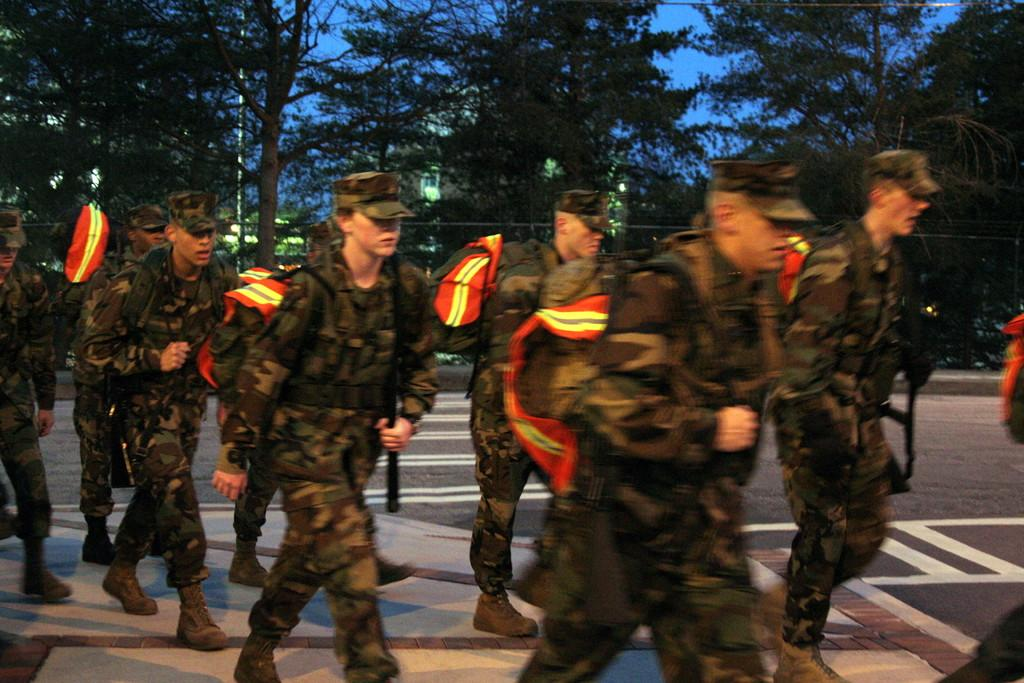Who is present in the image? There are men in the image. What are the men wearing? The men are wearing uniforms. What are the men doing in the image? The men are walking on the road. What can be seen in the background of the image? There are buildings, electric lights, trees, and the sky visible in the background of the image. What type of duck can be seen sitting on the sheet in the image? There is no duck or sheet present in the image; it features men walking on the road with a background of buildings, electric lights, trees, and the sky. 